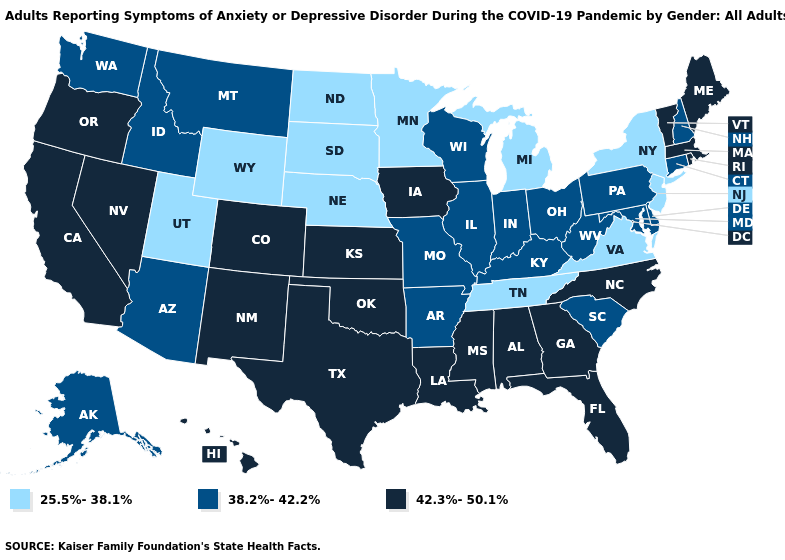Among the states that border Kansas , which have the highest value?
Quick response, please. Colorado, Oklahoma. Which states have the highest value in the USA?
Quick response, please. Alabama, California, Colorado, Florida, Georgia, Hawaii, Iowa, Kansas, Louisiana, Maine, Massachusetts, Mississippi, Nevada, New Mexico, North Carolina, Oklahoma, Oregon, Rhode Island, Texas, Vermont. Does the first symbol in the legend represent the smallest category?
Write a very short answer. Yes. What is the value of Missouri?
Be succinct. 38.2%-42.2%. What is the lowest value in states that border Tennessee?
Answer briefly. 25.5%-38.1%. Among the states that border South Carolina , which have the lowest value?
Keep it brief. Georgia, North Carolina. Does Wisconsin have the lowest value in the USA?
Short answer required. No. What is the highest value in states that border New Mexico?
Quick response, please. 42.3%-50.1%. Does North Dakota have the highest value in the MidWest?
Be succinct. No. What is the value of Washington?
Give a very brief answer. 38.2%-42.2%. Does South Dakota have the lowest value in the USA?
Quick response, please. Yes. Name the states that have a value in the range 25.5%-38.1%?
Concise answer only. Michigan, Minnesota, Nebraska, New Jersey, New York, North Dakota, South Dakota, Tennessee, Utah, Virginia, Wyoming. Does Washington have a higher value than Virginia?
Give a very brief answer. Yes. Does Alaska have the same value as Oklahoma?
Keep it brief. No. What is the lowest value in states that border Rhode Island?
Answer briefly. 38.2%-42.2%. 